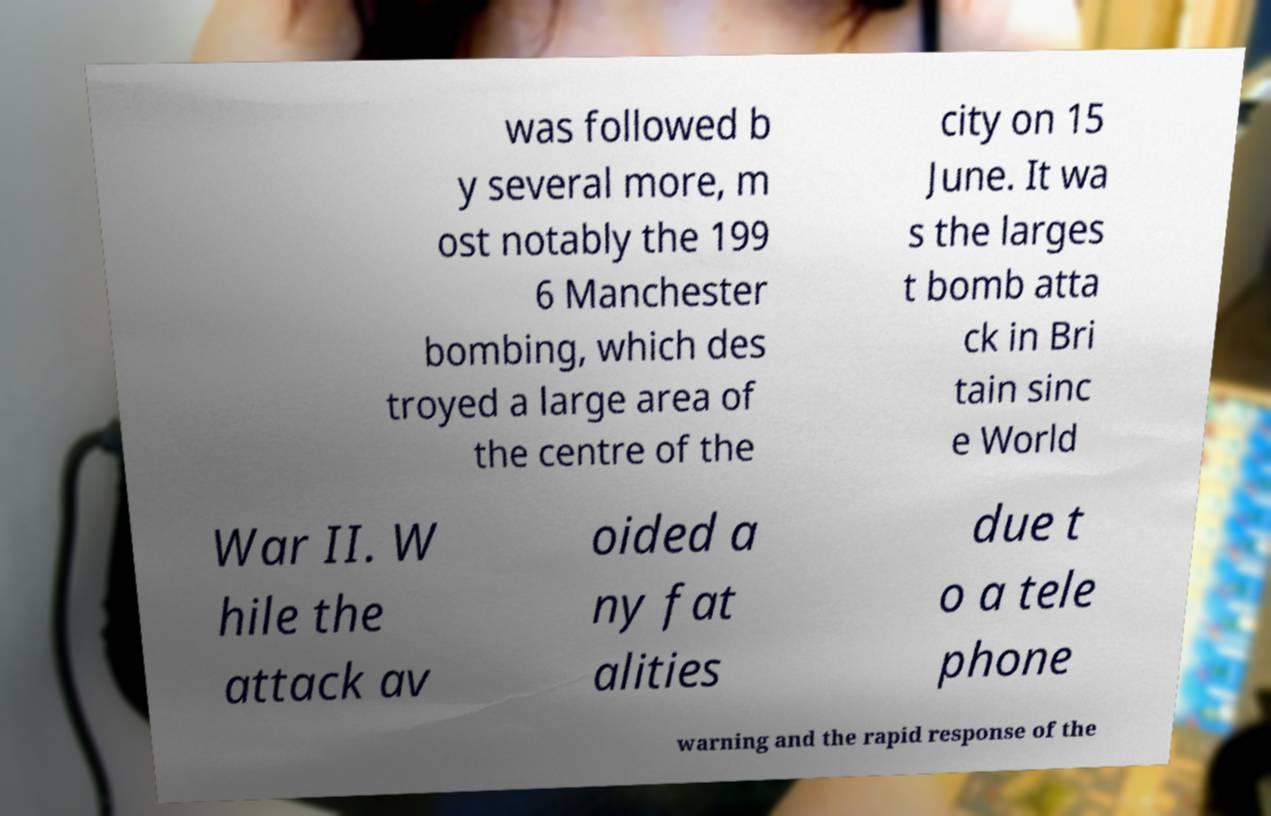Can you accurately transcribe the text from the provided image for me? was followed b y several more, m ost notably the 199 6 Manchester bombing, which des troyed a large area of the centre of the city on 15 June. It wa s the larges t bomb atta ck in Bri tain sinc e World War II. W hile the attack av oided a ny fat alities due t o a tele phone warning and the rapid response of the 